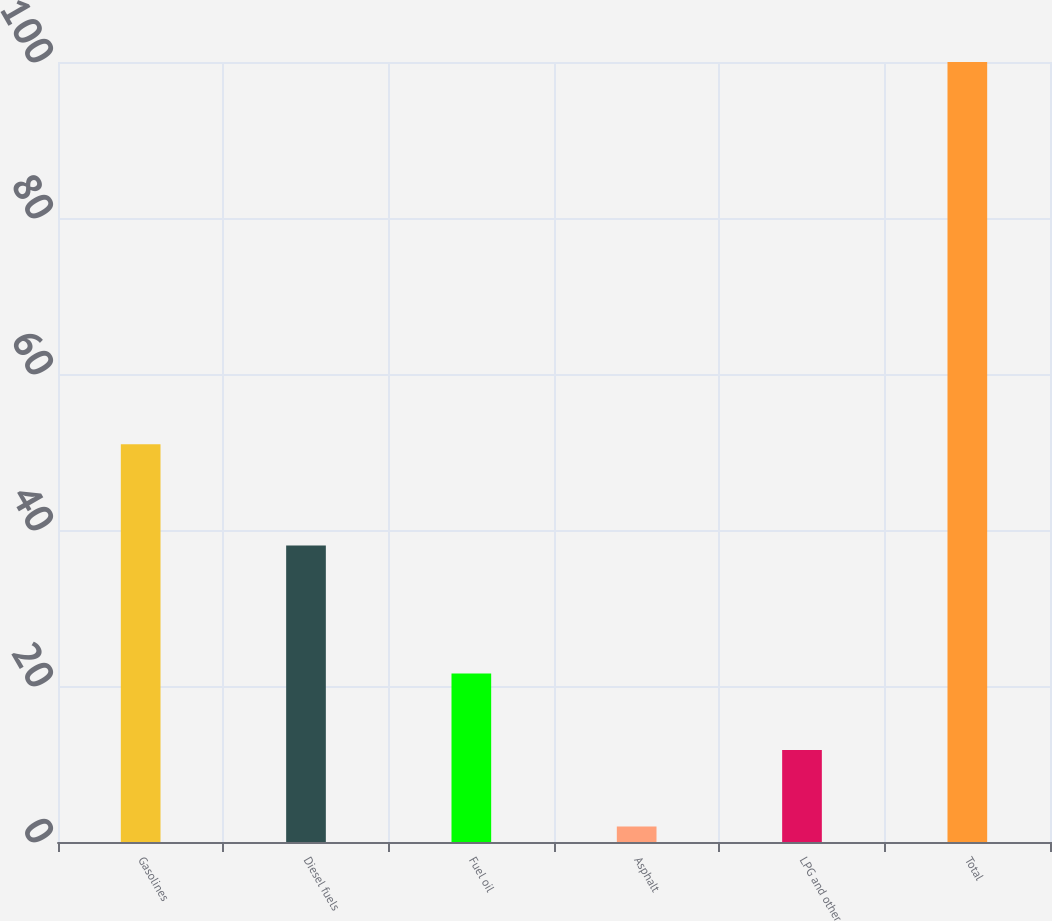Convert chart to OTSL. <chart><loc_0><loc_0><loc_500><loc_500><bar_chart><fcel>Gasolines<fcel>Diesel fuels<fcel>Fuel oil<fcel>Asphalt<fcel>LPG and other<fcel>Total<nl><fcel>51<fcel>38<fcel>21.6<fcel>2<fcel>11.8<fcel>100<nl></chart> 